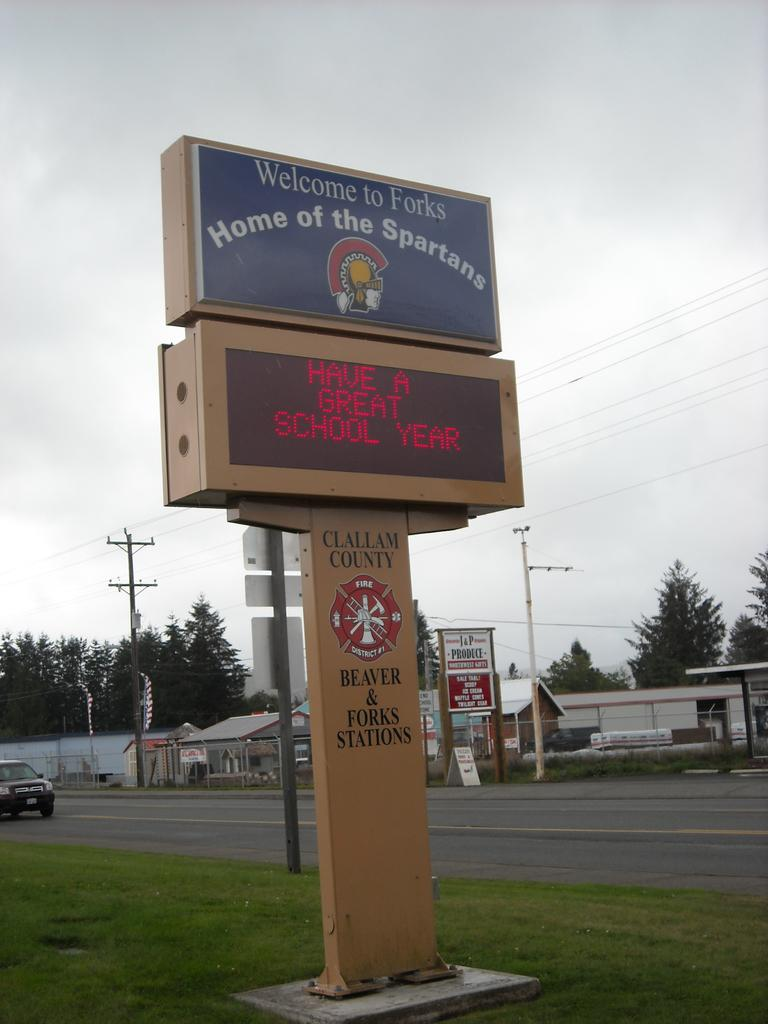<image>
Give a short and clear explanation of the subsequent image. Large school sigh that says "Have A Great School Year" as the ticker. 